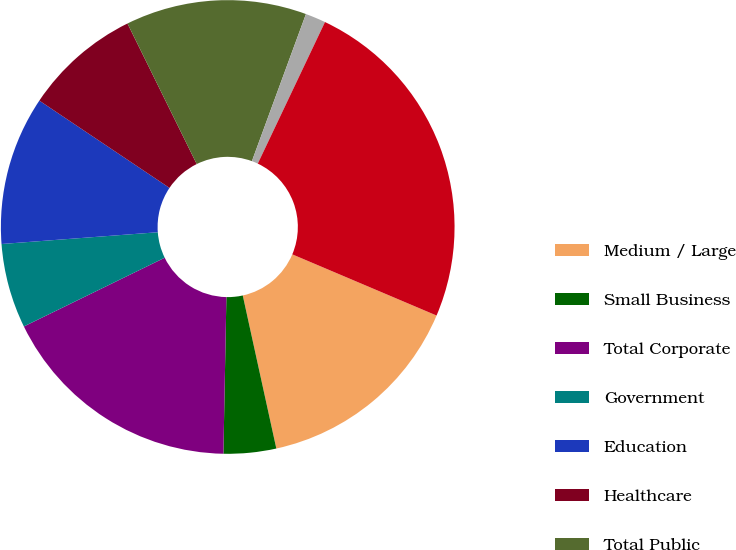Convert chart. <chart><loc_0><loc_0><loc_500><loc_500><pie_chart><fcel>Medium / Large<fcel>Small Business<fcel>Total Corporate<fcel>Government<fcel>Education<fcel>Healthcare<fcel>Total Public<fcel>Other<fcel>Total Net sales<nl><fcel>15.18%<fcel>3.74%<fcel>17.47%<fcel>6.03%<fcel>10.6%<fcel>8.31%<fcel>12.89%<fcel>1.45%<fcel>24.33%<nl></chart> 